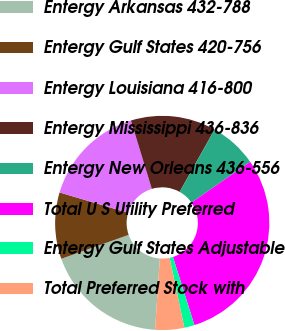<chart> <loc_0><loc_0><loc_500><loc_500><pie_chart><fcel>Entergy Arkansas 432-788<fcel>Entergy Gulf States 420-756<fcel>Entergy Louisiana 416-800<fcel>Entergy Mississippi 436-836<fcel>Entergy New Orleans 436-556<fcel>Total U S Utility Preferred<fcel>Entergy Gulf States Adjustable<fcel>Total Preferred Stock with<nl><fcel>18.5%<fcel>10.03%<fcel>15.68%<fcel>12.85%<fcel>7.2%<fcel>29.81%<fcel>1.55%<fcel>4.38%<nl></chart> 